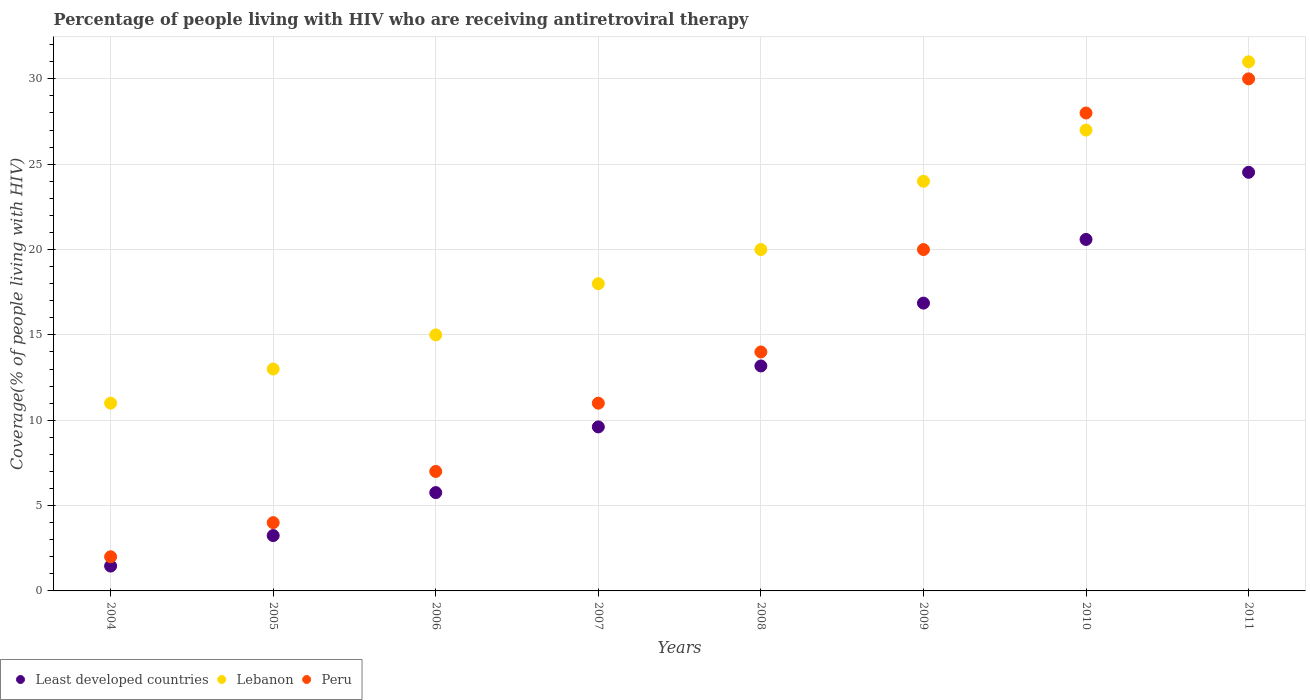What is the percentage of the HIV infected people who are receiving antiretroviral therapy in Least developed countries in 2009?
Your answer should be compact. 16.86. Across all years, what is the maximum percentage of the HIV infected people who are receiving antiretroviral therapy in Lebanon?
Provide a succinct answer. 31. Across all years, what is the minimum percentage of the HIV infected people who are receiving antiretroviral therapy in Peru?
Offer a very short reply. 2. What is the total percentage of the HIV infected people who are receiving antiretroviral therapy in Least developed countries in the graph?
Offer a terse response. 95.23. What is the difference between the percentage of the HIV infected people who are receiving antiretroviral therapy in Lebanon in 2007 and that in 2010?
Ensure brevity in your answer.  -9. What is the difference between the percentage of the HIV infected people who are receiving antiretroviral therapy in Peru in 2006 and the percentage of the HIV infected people who are receiving antiretroviral therapy in Least developed countries in 2010?
Your response must be concise. -13.59. What is the average percentage of the HIV infected people who are receiving antiretroviral therapy in Least developed countries per year?
Give a very brief answer. 11.9. In the year 2005, what is the difference between the percentage of the HIV infected people who are receiving antiretroviral therapy in Least developed countries and percentage of the HIV infected people who are receiving antiretroviral therapy in Peru?
Provide a succinct answer. -0.76. In how many years, is the percentage of the HIV infected people who are receiving antiretroviral therapy in Peru greater than 8 %?
Your answer should be very brief. 5. What is the ratio of the percentage of the HIV infected people who are receiving antiretroviral therapy in Least developed countries in 2004 to that in 2008?
Your answer should be very brief. 0.11. Is the percentage of the HIV infected people who are receiving antiretroviral therapy in Lebanon in 2007 less than that in 2009?
Keep it short and to the point. Yes. Is the difference between the percentage of the HIV infected people who are receiving antiretroviral therapy in Least developed countries in 2004 and 2010 greater than the difference between the percentage of the HIV infected people who are receiving antiretroviral therapy in Peru in 2004 and 2010?
Your answer should be compact. Yes. What is the difference between the highest and the lowest percentage of the HIV infected people who are receiving antiretroviral therapy in Least developed countries?
Make the answer very short. 23.07. Is the sum of the percentage of the HIV infected people who are receiving antiretroviral therapy in Least developed countries in 2005 and 2007 greater than the maximum percentage of the HIV infected people who are receiving antiretroviral therapy in Lebanon across all years?
Provide a succinct answer. No. Is it the case that in every year, the sum of the percentage of the HIV infected people who are receiving antiretroviral therapy in Least developed countries and percentage of the HIV infected people who are receiving antiretroviral therapy in Peru  is greater than the percentage of the HIV infected people who are receiving antiretroviral therapy in Lebanon?
Offer a very short reply. No. Is the percentage of the HIV infected people who are receiving antiretroviral therapy in Peru strictly less than the percentage of the HIV infected people who are receiving antiretroviral therapy in Lebanon over the years?
Provide a succinct answer. No. How many years are there in the graph?
Your answer should be very brief. 8. What is the difference between two consecutive major ticks on the Y-axis?
Make the answer very short. 5. Does the graph contain grids?
Your response must be concise. Yes. Where does the legend appear in the graph?
Provide a succinct answer. Bottom left. How many legend labels are there?
Ensure brevity in your answer.  3. What is the title of the graph?
Provide a short and direct response. Percentage of people living with HIV who are receiving antiretroviral therapy. Does "Canada" appear as one of the legend labels in the graph?
Give a very brief answer. No. What is the label or title of the Y-axis?
Give a very brief answer. Coverage(% of people living with HIV). What is the Coverage(% of people living with HIV) in Least developed countries in 2004?
Provide a short and direct response. 1.46. What is the Coverage(% of people living with HIV) in Peru in 2004?
Offer a very short reply. 2. What is the Coverage(% of people living with HIV) of Least developed countries in 2005?
Provide a short and direct response. 3.24. What is the Coverage(% of people living with HIV) of Lebanon in 2005?
Make the answer very short. 13. What is the Coverage(% of people living with HIV) of Peru in 2005?
Your answer should be very brief. 4. What is the Coverage(% of people living with HIV) in Least developed countries in 2006?
Offer a very short reply. 5.76. What is the Coverage(% of people living with HIV) of Lebanon in 2006?
Offer a terse response. 15. What is the Coverage(% of people living with HIV) in Peru in 2006?
Your answer should be very brief. 7. What is the Coverage(% of people living with HIV) of Least developed countries in 2007?
Provide a short and direct response. 9.61. What is the Coverage(% of people living with HIV) of Least developed countries in 2008?
Your answer should be compact. 13.18. What is the Coverage(% of people living with HIV) of Lebanon in 2008?
Ensure brevity in your answer.  20. What is the Coverage(% of people living with HIV) in Least developed countries in 2009?
Provide a short and direct response. 16.86. What is the Coverage(% of people living with HIV) of Lebanon in 2009?
Your answer should be compact. 24. What is the Coverage(% of people living with HIV) in Peru in 2009?
Offer a terse response. 20. What is the Coverage(% of people living with HIV) in Least developed countries in 2010?
Your response must be concise. 20.59. What is the Coverage(% of people living with HIV) of Lebanon in 2010?
Offer a terse response. 27. What is the Coverage(% of people living with HIV) of Least developed countries in 2011?
Provide a succinct answer. 24.53. What is the Coverage(% of people living with HIV) in Peru in 2011?
Your answer should be compact. 30. Across all years, what is the maximum Coverage(% of people living with HIV) of Least developed countries?
Make the answer very short. 24.53. Across all years, what is the minimum Coverage(% of people living with HIV) in Least developed countries?
Provide a short and direct response. 1.46. Across all years, what is the minimum Coverage(% of people living with HIV) in Lebanon?
Keep it short and to the point. 11. What is the total Coverage(% of people living with HIV) of Least developed countries in the graph?
Keep it short and to the point. 95.23. What is the total Coverage(% of people living with HIV) of Lebanon in the graph?
Make the answer very short. 159. What is the total Coverage(% of people living with HIV) of Peru in the graph?
Your answer should be very brief. 116. What is the difference between the Coverage(% of people living with HIV) in Least developed countries in 2004 and that in 2005?
Make the answer very short. -1.79. What is the difference between the Coverage(% of people living with HIV) of Least developed countries in 2004 and that in 2006?
Your response must be concise. -4.3. What is the difference between the Coverage(% of people living with HIV) in Peru in 2004 and that in 2006?
Provide a succinct answer. -5. What is the difference between the Coverage(% of people living with HIV) of Least developed countries in 2004 and that in 2007?
Provide a short and direct response. -8.15. What is the difference between the Coverage(% of people living with HIV) in Lebanon in 2004 and that in 2007?
Provide a short and direct response. -7. What is the difference between the Coverage(% of people living with HIV) of Peru in 2004 and that in 2007?
Offer a terse response. -9. What is the difference between the Coverage(% of people living with HIV) in Least developed countries in 2004 and that in 2008?
Give a very brief answer. -11.72. What is the difference between the Coverage(% of people living with HIV) in Lebanon in 2004 and that in 2008?
Your answer should be compact. -9. What is the difference between the Coverage(% of people living with HIV) in Least developed countries in 2004 and that in 2009?
Your answer should be very brief. -15.41. What is the difference between the Coverage(% of people living with HIV) of Least developed countries in 2004 and that in 2010?
Make the answer very short. -19.14. What is the difference between the Coverage(% of people living with HIV) in Lebanon in 2004 and that in 2010?
Keep it short and to the point. -16. What is the difference between the Coverage(% of people living with HIV) of Least developed countries in 2004 and that in 2011?
Offer a very short reply. -23.07. What is the difference between the Coverage(% of people living with HIV) of Peru in 2004 and that in 2011?
Provide a short and direct response. -28. What is the difference between the Coverage(% of people living with HIV) in Least developed countries in 2005 and that in 2006?
Offer a very short reply. -2.52. What is the difference between the Coverage(% of people living with HIV) of Lebanon in 2005 and that in 2006?
Ensure brevity in your answer.  -2. What is the difference between the Coverage(% of people living with HIV) in Peru in 2005 and that in 2006?
Ensure brevity in your answer.  -3. What is the difference between the Coverage(% of people living with HIV) in Least developed countries in 2005 and that in 2007?
Offer a very short reply. -6.37. What is the difference between the Coverage(% of people living with HIV) of Lebanon in 2005 and that in 2007?
Your answer should be compact. -5. What is the difference between the Coverage(% of people living with HIV) in Least developed countries in 2005 and that in 2008?
Your answer should be compact. -9.94. What is the difference between the Coverage(% of people living with HIV) of Peru in 2005 and that in 2008?
Your answer should be very brief. -10. What is the difference between the Coverage(% of people living with HIV) of Least developed countries in 2005 and that in 2009?
Give a very brief answer. -13.62. What is the difference between the Coverage(% of people living with HIV) of Lebanon in 2005 and that in 2009?
Offer a very short reply. -11. What is the difference between the Coverage(% of people living with HIV) of Least developed countries in 2005 and that in 2010?
Your response must be concise. -17.35. What is the difference between the Coverage(% of people living with HIV) of Lebanon in 2005 and that in 2010?
Offer a very short reply. -14. What is the difference between the Coverage(% of people living with HIV) in Peru in 2005 and that in 2010?
Keep it short and to the point. -24. What is the difference between the Coverage(% of people living with HIV) of Least developed countries in 2005 and that in 2011?
Give a very brief answer. -21.28. What is the difference between the Coverage(% of people living with HIV) of Lebanon in 2005 and that in 2011?
Give a very brief answer. -18. What is the difference between the Coverage(% of people living with HIV) of Least developed countries in 2006 and that in 2007?
Keep it short and to the point. -3.85. What is the difference between the Coverage(% of people living with HIV) in Peru in 2006 and that in 2007?
Your answer should be compact. -4. What is the difference between the Coverage(% of people living with HIV) of Least developed countries in 2006 and that in 2008?
Give a very brief answer. -7.42. What is the difference between the Coverage(% of people living with HIV) of Lebanon in 2006 and that in 2008?
Keep it short and to the point. -5. What is the difference between the Coverage(% of people living with HIV) in Peru in 2006 and that in 2008?
Keep it short and to the point. -7. What is the difference between the Coverage(% of people living with HIV) of Least developed countries in 2006 and that in 2009?
Your answer should be compact. -11.1. What is the difference between the Coverage(% of people living with HIV) of Lebanon in 2006 and that in 2009?
Your response must be concise. -9. What is the difference between the Coverage(% of people living with HIV) in Peru in 2006 and that in 2009?
Provide a short and direct response. -13. What is the difference between the Coverage(% of people living with HIV) of Least developed countries in 2006 and that in 2010?
Your answer should be very brief. -14.83. What is the difference between the Coverage(% of people living with HIV) in Peru in 2006 and that in 2010?
Your answer should be very brief. -21. What is the difference between the Coverage(% of people living with HIV) in Least developed countries in 2006 and that in 2011?
Keep it short and to the point. -18.76. What is the difference between the Coverage(% of people living with HIV) of Peru in 2006 and that in 2011?
Offer a terse response. -23. What is the difference between the Coverage(% of people living with HIV) in Least developed countries in 2007 and that in 2008?
Your response must be concise. -3.57. What is the difference between the Coverage(% of people living with HIV) in Lebanon in 2007 and that in 2008?
Keep it short and to the point. -2. What is the difference between the Coverage(% of people living with HIV) of Least developed countries in 2007 and that in 2009?
Ensure brevity in your answer.  -7.25. What is the difference between the Coverage(% of people living with HIV) of Lebanon in 2007 and that in 2009?
Keep it short and to the point. -6. What is the difference between the Coverage(% of people living with HIV) in Least developed countries in 2007 and that in 2010?
Keep it short and to the point. -10.98. What is the difference between the Coverage(% of people living with HIV) of Lebanon in 2007 and that in 2010?
Your answer should be very brief. -9. What is the difference between the Coverage(% of people living with HIV) in Least developed countries in 2007 and that in 2011?
Offer a very short reply. -14.92. What is the difference between the Coverage(% of people living with HIV) in Peru in 2007 and that in 2011?
Give a very brief answer. -19. What is the difference between the Coverage(% of people living with HIV) of Least developed countries in 2008 and that in 2009?
Give a very brief answer. -3.68. What is the difference between the Coverage(% of people living with HIV) in Peru in 2008 and that in 2009?
Give a very brief answer. -6. What is the difference between the Coverage(% of people living with HIV) of Least developed countries in 2008 and that in 2010?
Your answer should be compact. -7.41. What is the difference between the Coverage(% of people living with HIV) in Peru in 2008 and that in 2010?
Provide a short and direct response. -14. What is the difference between the Coverage(% of people living with HIV) of Least developed countries in 2008 and that in 2011?
Your answer should be very brief. -11.35. What is the difference between the Coverage(% of people living with HIV) in Lebanon in 2008 and that in 2011?
Give a very brief answer. -11. What is the difference between the Coverage(% of people living with HIV) in Least developed countries in 2009 and that in 2010?
Provide a short and direct response. -3.73. What is the difference between the Coverage(% of people living with HIV) in Lebanon in 2009 and that in 2010?
Make the answer very short. -3. What is the difference between the Coverage(% of people living with HIV) in Peru in 2009 and that in 2010?
Offer a very short reply. -8. What is the difference between the Coverage(% of people living with HIV) in Least developed countries in 2009 and that in 2011?
Provide a succinct answer. -7.66. What is the difference between the Coverage(% of people living with HIV) of Least developed countries in 2010 and that in 2011?
Give a very brief answer. -3.93. What is the difference between the Coverage(% of people living with HIV) of Lebanon in 2010 and that in 2011?
Make the answer very short. -4. What is the difference between the Coverage(% of people living with HIV) in Least developed countries in 2004 and the Coverage(% of people living with HIV) in Lebanon in 2005?
Your answer should be compact. -11.54. What is the difference between the Coverage(% of people living with HIV) in Least developed countries in 2004 and the Coverage(% of people living with HIV) in Peru in 2005?
Offer a terse response. -2.54. What is the difference between the Coverage(% of people living with HIV) of Least developed countries in 2004 and the Coverage(% of people living with HIV) of Lebanon in 2006?
Offer a terse response. -13.54. What is the difference between the Coverage(% of people living with HIV) of Least developed countries in 2004 and the Coverage(% of people living with HIV) of Peru in 2006?
Your answer should be very brief. -5.54. What is the difference between the Coverage(% of people living with HIV) of Lebanon in 2004 and the Coverage(% of people living with HIV) of Peru in 2006?
Offer a very short reply. 4. What is the difference between the Coverage(% of people living with HIV) of Least developed countries in 2004 and the Coverage(% of people living with HIV) of Lebanon in 2007?
Your answer should be very brief. -16.54. What is the difference between the Coverage(% of people living with HIV) of Least developed countries in 2004 and the Coverage(% of people living with HIV) of Peru in 2007?
Offer a terse response. -9.54. What is the difference between the Coverage(% of people living with HIV) of Lebanon in 2004 and the Coverage(% of people living with HIV) of Peru in 2007?
Your answer should be very brief. 0. What is the difference between the Coverage(% of people living with HIV) in Least developed countries in 2004 and the Coverage(% of people living with HIV) in Lebanon in 2008?
Make the answer very short. -18.54. What is the difference between the Coverage(% of people living with HIV) in Least developed countries in 2004 and the Coverage(% of people living with HIV) in Peru in 2008?
Your answer should be compact. -12.54. What is the difference between the Coverage(% of people living with HIV) of Least developed countries in 2004 and the Coverage(% of people living with HIV) of Lebanon in 2009?
Keep it short and to the point. -22.54. What is the difference between the Coverage(% of people living with HIV) of Least developed countries in 2004 and the Coverage(% of people living with HIV) of Peru in 2009?
Offer a terse response. -18.54. What is the difference between the Coverage(% of people living with HIV) in Least developed countries in 2004 and the Coverage(% of people living with HIV) in Lebanon in 2010?
Ensure brevity in your answer.  -25.54. What is the difference between the Coverage(% of people living with HIV) in Least developed countries in 2004 and the Coverage(% of people living with HIV) in Peru in 2010?
Ensure brevity in your answer.  -26.54. What is the difference between the Coverage(% of people living with HIV) of Least developed countries in 2004 and the Coverage(% of people living with HIV) of Lebanon in 2011?
Provide a succinct answer. -29.54. What is the difference between the Coverage(% of people living with HIV) of Least developed countries in 2004 and the Coverage(% of people living with HIV) of Peru in 2011?
Your answer should be compact. -28.54. What is the difference between the Coverage(% of people living with HIV) in Lebanon in 2004 and the Coverage(% of people living with HIV) in Peru in 2011?
Give a very brief answer. -19. What is the difference between the Coverage(% of people living with HIV) of Least developed countries in 2005 and the Coverage(% of people living with HIV) of Lebanon in 2006?
Keep it short and to the point. -11.76. What is the difference between the Coverage(% of people living with HIV) in Least developed countries in 2005 and the Coverage(% of people living with HIV) in Peru in 2006?
Give a very brief answer. -3.76. What is the difference between the Coverage(% of people living with HIV) in Least developed countries in 2005 and the Coverage(% of people living with HIV) in Lebanon in 2007?
Offer a terse response. -14.76. What is the difference between the Coverage(% of people living with HIV) of Least developed countries in 2005 and the Coverage(% of people living with HIV) of Peru in 2007?
Offer a terse response. -7.76. What is the difference between the Coverage(% of people living with HIV) of Least developed countries in 2005 and the Coverage(% of people living with HIV) of Lebanon in 2008?
Ensure brevity in your answer.  -16.76. What is the difference between the Coverage(% of people living with HIV) of Least developed countries in 2005 and the Coverage(% of people living with HIV) of Peru in 2008?
Your answer should be very brief. -10.76. What is the difference between the Coverage(% of people living with HIV) in Lebanon in 2005 and the Coverage(% of people living with HIV) in Peru in 2008?
Keep it short and to the point. -1. What is the difference between the Coverage(% of people living with HIV) in Least developed countries in 2005 and the Coverage(% of people living with HIV) in Lebanon in 2009?
Offer a very short reply. -20.76. What is the difference between the Coverage(% of people living with HIV) of Least developed countries in 2005 and the Coverage(% of people living with HIV) of Peru in 2009?
Give a very brief answer. -16.76. What is the difference between the Coverage(% of people living with HIV) of Least developed countries in 2005 and the Coverage(% of people living with HIV) of Lebanon in 2010?
Your response must be concise. -23.76. What is the difference between the Coverage(% of people living with HIV) of Least developed countries in 2005 and the Coverage(% of people living with HIV) of Peru in 2010?
Give a very brief answer. -24.76. What is the difference between the Coverage(% of people living with HIV) of Lebanon in 2005 and the Coverage(% of people living with HIV) of Peru in 2010?
Provide a succinct answer. -15. What is the difference between the Coverage(% of people living with HIV) of Least developed countries in 2005 and the Coverage(% of people living with HIV) of Lebanon in 2011?
Offer a very short reply. -27.76. What is the difference between the Coverage(% of people living with HIV) of Least developed countries in 2005 and the Coverage(% of people living with HIV) of Peru in 2011?
Your answer should be compact. -26.76. What is the difference between the Coverage(% of people living with HIV) in Lebanon in 2005 and the Coverage(% of people living with HIV) in Peru in 2011?
Offer a terse response. -17. What is the difference between the Coverage(% of people living with HIV) in Least developed countries in 2006 and the Coverage(% of people living with HIV) in Lebanon in 2007?
Give a very brief answer. -12.24. What is the difference between the Coverage(% of people living with HIV) in Least developed countries in 2006 and the Coverage(% of people living with HIV) in Peru in 2007?
Give a very brief answer. -5.24. What is the difference between the Coverage(% of people living with HIV) of Least developed countries in 2006 and the Coverage(% of people living with HIV) of Lebanon in 2008?
Your answer should be compact. -14.24. What is the difference between the Coverage(% of people living with HIV) in Least developed countries in 2006 and the Coverage(% of people living with HIV) in Peru in 2008?
Make the answer very short. -8.24. What is the difference between the Coverage(% of people living with HIV) in Least developed countries in 2006 and the Coverage(% of people living with HIV) in Lebanon in 2009?
Provide a short and direct response. -18.24. What is the difference between the Coverage(% of people living with HIV) of Least developed countries in 2006 and the Coverage(% of people living with HIV) of Peru in 2009?
Provide a succinct answer. -14.24. What is the difference between the Coverage(% of people living with HIV) of Least developed countries in 2006 and the Coverage(% of people living with HIV) of Lebanon in 2010?
Your answer should be compact. -21.24. What is the difference between the Coverage(% of people living with HIV) in Least developed countries in 2006 and the Coverage(% of people living with HIV) in Peru in 2010?
Keep it short and to the point. -22.24. What is the difference between the Coverage(% of people living with HIV) of Lebanon in 2006 and the Coverage(% of people living with HIV) of Peru in 2010?
Make the answer very short. -13. What is the difference between the Coverage(% of people living with HIV) of Least developed countries in 2006 and the Coverage(% of people living with HIV) of Lebanon in 2011?
Make the answer very short. -25.24. What is the difference between the Coverage(% of people living with HIV) in Least developed countries in 2006 and the Coverage(% of people living with HIV) in Peru in 2011?
Make the answer very short. -24.24. What is the difference between the Coverage(% of people living with HIV) in Least developed countries in 2007 and the Coverage(% of people living with HIV) in Lebanon in 2008?
Provide a succinct answer. -10.39. What is the difference between the Coverage(% of people living with HIV) of Least developed countries in 2007 and the Coverage(% of people living with HIV) of Peru in 2008?
Keep it short and to the point. -4.39. What is the difference between the Coverage(% of people living with HIV) of Least developed countries in 2007 and the Coverage(% of people living with HIV) of Lebanon in 2009?
Offer a terse response. -14.39. What is the difference between the Coverage(% of people living with HIV) of Least developed countries in 2007 and the Coverage(% of people living with HIV) of Peru in 2009?
Your answer should be very brief. -10.39. What is the difference between the Coverage(% of people living with HIV) in Least developed countries in 2007 and the Coverage(% of people living with HIV) in Lebanon in 2010?
Give a very brief answer. -17.39. What is the difference between the Coverage(% of people living with HIV) in Least developed countries in 2007 and the Coverage(% of people living with HIV) in Peru in 2010?
Offer a very short reply. -18.39. What is the difference between the Coverage(% of people living with HIV) of Lebanon in 2007 and the Coverage(% of people living with HIV) of Peru in 2010?
Keep it short and to the point. -10. What is the difference between the Coverage(% of people living with HIV) in Least developed countries in 2007 and the Coverage(% of people living with HIV) in Lebanon in 2011?
Provide a short and direct response. -21.39. What is the difference between the Coverage(% of people living with HIV) of Least developed countries in 2007 and the Coverage(% of people living with HIV) of Peru in 2011?
Offer a very short reply. -20.39. What is the difference between the Coverage(% of people living with HIV) of Least developed countries in 2008 and the Coverage(% of people living with HIV) of Lebanon in 2009?
Make the answer very short. -10.82. What is the difference between the Coverage(% of people living with HIV) of Least developed countries in 2008 and the Coverage(% of people living with HIV) of Peru in 2009?
Give a very brief answer. -6.82. What is the difference between the Coverage(% of people living with HIV) in Least developed countries in 2008 and the Coverage(% of people living with HIV) in Lebanon in 2010?
Provide a succinct answer. -13.82. What is the difference between the Coverage(% of people living with HIV) of Least developed countries in 2008 and the Coverage(% of people living with HIV) of Peru in 2010?
Make the answer very short. -14.82. What is the difference between the Coverage(% of people living with HIV) of Least developed countries in 2008 and the Coverage(% of people living with HIV) of Lebanon in 2011?
Offer a very short reply. -17.82. What is the difference between the Coverage(% of people living with HIV) in Least developed countries in 2008 and the Coverage(% of people living with HIV) in Peru in 2011?
Provide a succinct answer. -16.82. What is the difference between the Coverage(% of people living with HIV) in Least developed countries in 2009 and the Coverage(% of people living with HIV) in Lebanon in 2010?
Your answer should be very brief. -10.14. What is the difference between the Coverage(% of people living with HIV) of Least developed countries in 2009 and the Coverage(% of people living with HIV) of Peru in 2010?
Ensure brevity in your answer.  -11.14. What is the difference between the Coverage(% of people living with HIV) of Least developed countries in 2009 and the Coverage(% of people living with HIV) of Lebanon in 2011?
Provide a succinct answer. -14.14. What is the difference between the Coverage(% of people living with HIV) in Least developed countries in 2009 and the Coverage(% of people living with HIV) in Peru in 2011?
Your answer should be very brief. -13.14. What is the difference between the Coverage(% of people living with HIV) of Lebanon in 2009 and the Coverage(% of people living with HIV) of Peru in 2011?
Your answer should be very brief. -6. What is the difference between the Coverage(% of people living with HIV) in Least developed countries in 2010 and the Coverage(% of people living with HIV) in Lebanon in 2011?
Ensure brevity in your answer.  -10.41. What is the difference between the Coverage(% of people living with HIV) of Least developed countries in 2010 and the Coverage(% of people living with HIV) of Peru in 2011?
Your response must be concise. -9.41. What is the difference between the Coverage(% of people living with HIV) of Lebanon in 2010 and the Coverage(% of people living with HIV) of Peru in 2011?
Provide a short and direct response. -3. What is the average Coverage(% of people living with HIV) of Least developed countries per year?
Give a very brief answer. 11.9. What is the average Coverage(% of people living with HIV) of Lebanon per year?
Provide a short and direct response. 19.88. In the year 2004, what is the difference between the Coverage(% of people living with HIV) in Least developed countries and Coverage(% of people living with HIV) in Lebanon?
Provide a short and direct response. -9.54. In the year 2004, what is the difference between the Coverage(% of people living with HIV) in Least developed countries and Coverage(% of people living with HIV) in Peru?
Make the answer very short. -0.54. In the year 2004, what is the difference between the Coverage(% of people living with HIV) of Lebanon and Coverage(% of people living with HIV) of Peru?
Your answer should be compact. 9. In the year 2005, what is the difference between the Coverage(% of people living with HIV) in Least developed countries and Coverage(% of people living with HIV) in Lebanon?
Make the answer very short. -9.76. In the year 2005, what is the difference between the Coverage(% of people living with HIV) of Least developed countries and Coverage(% of people living with HIV) of Peru?
Make the answer very short. -0.76. In the year 2006, what is the difference between the Coverage(% of people living with HIV) of Least developed countries and Coverage(% of people living with HIV) of Lebanon?
Provide a short and direct response. -9.24. In the year 2006, what is the difference between the Coverage(% of people living with HIV) of Least developed countries and Coverage(% of people living with HIV) of Peru?
Keep it short and to the point. -1.24. In the year 2006, what is the difference between the Coverage(% of people living with HIV) of Lebanon and Coverage(% of people living with HIV) of Peru?
Provide a short and direct response. 8. In the year 2007, what is the difference between the Coverage(% of people living with HIV) of Least developed countries and Coverage(% of people living with HIV) of Lebanon?
Provide a short and direct response. -8.39. In the year 2007, what is the difference between the Coverage(% of people living with HIV) in Least developed countries and Coverage(% of people living with HIV) in Peru?
Your response must be concise. -1.39. In the year 2007, what is the difference between the Coverage(% of people living with HIV) of Lebanon and Coverage(% of people living with HIV) of Peru?
Offer a very short reply. 7. In the year 2008, what is the difference between the Coverage(% of people living with HIV) in Least developed countries and Coverage(% of people living with HIV) in Lebanon?
Offer a terse response. -6.82. In the year 2008, what is the difference between the Coverage(% of people living with HIV) of Least developed countries and Coverage(% of people living with HIV) of Peru?
Ensure brevity in your answer.  -0.82. In the year 2008, what is the difference between the Coverage(% of people living with HIV) in Lebanon and Coverage(% of people living with HIV) in Peru?
Keep it short and to the point. 6. In the year 2009, what is the difference between the Coverage(% of people living with HIV) of Least developed countries and Coverage(% of people living with HIV) of Lebanon?
Provide a short and direct response. -7.14. In the year 2009, what is the difference between the Coverage(% of people living with HIV) in Least developed countries and Coverage(% of people living with HIV) in Peru?
Your answer should be compact. -3.14. In the year 2010, what is the difference between the Coverage(% of people living with HIV) in Least developed countries and Coverage(% of people living with HIV) in Lebanon?
Keep it short and to the point. -6.41. In the year 2010, what is the difference between the Coverage(% of people living with HIV) in Least developed countries and Coverage(% of people living with HIV) in Peru?
Provide a short and direct response. -7.41. In the year 2010, what is the difference between the Coverage(% of people living with HIV) in Lebanon and Coverage(% of people living with HIV) in Peru?
Keep it short and to the point. -1. In the year 2011, what is the difference between the Coverage(% of people living with HIV) of Least developed countries and Coverage(% of people living with HIV) of Lebanon?
Keep it short and to the point. -6.47. In the year 2011, what is the difference between the Coverage(% of people living with HIV) in Least developed countries and Coverage(% of people living with HIV) in Peru?
Offer a terse response. -5.47. In the year 2011, what is the difference between the Coverage(% of people living with HIV) of Lebanon and Coverage(% of people living with HIV) of Peru?
Provide a short and direct response. 1. What is the ratio of the Coverage(% of people living with HIV) in Least developed countries in 2004 to that in 2005?
Ensure brevity in your answer.  0.45. What is the ratio of the Coverage(% of people living with HIV) of Lebanon in 2004 to that in 2005?
Your response must be concise. 0.85. What is the ratio of the Coverage(% of people living with HIV) in Least developed countries in 2004 to that in 2006?
Offer a very short reply. 0.25. What is the ratio of the Coverage(% of people living with HIV) of Lebanon in 2004 to that in 2006?
Your response must be concise. 0.73. What is the ratio of the Coverage(% of people living with HIV) in Peru in 2004 to that in 2006?
Provide a succinct answer. 0.29. What is the ratio of the Coverage(% of people living with HIV) in Least developed countries in 2004 to that in 2007?
Provide a succinct answer. 0.15. What is the ratio of the Coverage(% of people living with HIV) in Lebanon in 2004 to that in 2007?
Keep it short and to the point. 0.61. What is the ratio of the Coverage(% of people living with HIV) of Peru in 2004 to that in 2007?
Give a very brief answer. 0.18. What is the ratio of the Coverage(% of people living with HIV) in Least developed countries in 2004 to that in 2008?
Offer a very short reply. 0.11. What is the ratio of the Coverage(% of people living with HIV) in Lebanon in 2004 to that in 2008?
Offer a terse response. 0.55. What is the ratio of the Coverage(% of people living with HIV) of Peru in 2004 to that in 2008?
Give a very brief answer. 0.14. What is the ratio of the Coverage(% of people living with HIV) in Least developed countries in 2004 to that in 2009?
Ensure brevity in your answer.  0.09. What is the ratio of the Coverage(% of people living with HIV) in Lebanon in 2004 to that in 2009?
Offer a terse response. 0.46. What is the ratio of the Coverage(% of people living with HIV) in Least developed countries in 2004 to that in 2010?
Ensure brevity in your answer.  0.07. What is the ratio of the Coverage(% of people living with HIV) of Lebanon in 2004 to that in 2010?
Keep it short and to the point. 0.41. What is the ratio of the Coverage(% of people living with HIV) of Peru in 2004 to that in 2010?
Provide a succinct answer. 0.07. What is the ratio of the Coverage(% of people living with HIV) in Least developed countries in 2004 to that in 2011?
Offer a very short reply. 0.06. What is the ratio of the Coverage(% of people living with HIV) in Lebanon in 2004 to that in 2011?
Your response must be concise. 0.35. What is the ratio of the Coverage(% of people living with HIV) in Peru in 2004 to that in 2011?
Offer a very short reply. 0.07. What is the ratio of the Coverage(% of people living with HIV) in Least developed countries in 2005 to that in 2006?
Keep it short and to the point. 0.56. What is the ratio of the Coverage(% of people living with HIV) of Lebanon in 2005 to that in 2006?
Offer a very short reply. 0.87. What is the ratio of the Coverage(% of people living with HIV) in Least developed countries in 2005 to that in 2007?
Your answer should be compact. 0.34. What is the ratio of the Coverage(% of people living with HIV) in Lebanon in 2005 to that in 2007?
Ensure brevity in your answer.  0.72. What is the ratio of the Coverage(% of people living with HIV) in Peru in 2005 to that in 2007?
Provide a short and direct response. 0.36. What is the ratio of the Coverage(% of people living with HIV) of Least developed countries in 2005 to that in 2008?
Offer a very short reply. 0.25. What is the ratio of the Coverage(% of people living with HIV) in Lebanon in 2005 to that in 2008?
Your response must be concise. 0.65. What is the ratio of the Coverage(% of people living with HIV) in Peru in 2005 to that in 2008?
Ensure brevity in your answer.  0.29. What is the ratio of the Coverage(% of people living with HIV) of Least developed countries in 2005 to that in 2009?
Provide a succinct answer. 0.19. What is the ratio of the Coverage(% of people living with HIV) of Lebanon in 2005 to that in 2009?
Make the answer very short. 0.54. What is the ratio of the Coverage(% of people living with HIV) in Peru in 2005 to that in 2009?
Provide a short and direct response. 0.2. What is the ratio of the Coverage(% of people living with HIV) in Least developed countries in 2005 to that in 2010?
Your answer should be compact. 0.16. What is the ratio of the Coverage(% of people living with HIV) in Lebanon in 2005 to that in 2010?
Give a very brief answer. 0.48. What is the ratio of the Coverage(% of people living with HIV) of Peru in 2005 to that in 2010?
Give a very brief answer. 0.14. What is the ratio of the Coverage(% of people living with HIV) in Least developed countries in 2005 to that in 2011?
Ensure brevity in your answer.  0.13. What is the ratio of the Coverage(% of people living with HIV) of Lebanon in 2005 to that in 2011?
Provide a succinct answer. 0.42. What is the ratio of the Coverage(% of people living with HIV) of Peru in 2005 to that in 2011?
Your answer should be very brief. 0.13. What is the ratio of the Coverage(% of people living with HIV) of Least developed countries in 2006 to that in 2007?
Provide a short and direct response. 0.6. What is the ratio of the Coverage(% of people living with HIV) in Peru in 2006 to that in 2007?
Provide a succinct answer. 0.64. What is the ratio of the Coverage(% of people living with HIV) of Least developed countries in 2006 to that in 2008?
Provide a short and direct response. 0.44. What is the ratio of the Coverage(% of people living with HIV) of Lebanon in 2006 to that in 2008?
Offer a terse response. 0.75. What is the ratio of the Coverage(% of people living with HIV) of Peru in 2006 to that in 2008?
Offer a very short reply. 0.5. What is the ratio of the Coverage(% of people living with HIV) in Least developed countries in 2006 to that in 2009?
Your response must be concise. 0.34. What is the ratio of the Coverage(% of people living with HIV) of Lebanon in 2006 to that in 2009?
Your answer should be very brief. 0.62. What is the ratio of the Coverage(% of people living with HIV) of Peru in 2006 to that in 2009?
Your response must be concise. 0.35. What is the ratio of the Coverage(% of people living with HIV) in Least developed countries in 2006 to that in 2010?
Make the answer very short. 0.28. What is the ratio of the Coverage(% of people living with HIV) of Lebanon in 2006 to that in 2010?
Provide a succinct answer. 0.56. What is the ratio of the Coverage(% of people living with HIV) of Peru in 2006 to that in 2010?
Make the answer very short. 0.25. What is the ratio of the Coverage(% of people living with HIV) of Least developed countries in 2006 to that in 2011?
Your response must be concise. 0.23. What is the ratio of the Coverage(% of people living with HIV) in Lebanon in 2006 to that in 2011?
Ensure brevity in your answer.  0.48. What is the ratio of the Coverage(% of people living with HIV) in Peru in 2006 to that in 2011?
Ensure brevity in your answer.  0.23. What is the ratio of the Coverage(% of people living with HIV) in Least developed countries in 2007 to that in 2008?
Keep it short and to the point. 0.73. What is the ratio of the Coverage(% of people living with HIV) in Lebanon in 2007 to that in 2008?
Ensure brevity in your answer.  0.9. What is the ratio of the Coverage(% of people living with HIV) of Peru in 2007 to that in 2008?
Your answer should be very brief. 0.79. What is the ratio of the Coverage(% of people living with HIV) in Least developed countries in 2007 to that in 2009?
Keep it short and to the point. 0.57. What is the ratio of the Coverage(% of people living with HIV) in Peru in 2007 to that in 2009?
Give a very brief answer. 0.55. What is the ratio of the Coverage(% of people living with HIV) in Least developed countries in 2007 to that in 2010?
Your answer should be compact. 0.47. What is the ratio of the Coverage(% of people living with HIV) of Peru in 2007 to that in 2010?
Ensure brevity in your answer.  0.39. What is the ratio of the Coverage(% of people living with HIV) in Least developed countries in 2007 to that in 2011?
Offer a terse response. 0.39. What is the ratio of the Coverage(% of people living with HIV) of Lebanon in 2007 to that in 2011?
Your response must be concise. 0.58. What is the ratio of the Coverage(% of people living with HIV) of Peru in 2007 to that in 2011?
Offer a very short reply. 0.37. What is the ratio of the Coverage(% of people living with HIV) in Least developed countries in 2008 to that in 2009?
Offer a terse response. 0.78. What is the ratio of the Coverage(% of people living with HIV) of Least developed countries in 2008 to that in 2010?
Your answer should be compact. 0.64. What is the ratio of the Coverage(% of people living with HIV) in Lebanon in 2008 to that in 2010?
Offer a very short reply. 0.74. What is the ratio of the Coverage(% of people living with HIV) in Least developed countries in 2008 to that in 2011?
Your answer should be compact. 0.54. What is the ratio of the Coverage(% of people living with HIV) in Lebanon in 2008 to that in 2011?
Give a very brief answer. 0.65. What is the ratio of the Coverage(% of people living with HIV) of Peru in 2008 to that in 2011?
Your answer should be very brief. 0.47. What is the ratio of the Coverage(% of people living with HIV) in Least developed countries in 2009 to that in 2010?
Provide a short and direct response. 0.82. What is the ratio of the Coverage(% of people living with HIV) of Lebanon in 2009 to that in 2010?
Your answer should be compact. 0.89. What is the ratio of the Coverage(% of people living with HIV) in Least developed countries in 2009 to that in 2011?
Your answer should be compact. 0.69. What is the ratio of the Coverage(% of people living with HIV) of Lebanon in 2009 to that in 2011?
Your answer should be very brief. 0.77. What is the ratio of the Coverage(% of people living with HIV) of Least developed countries in 2010 to that in 2011?
Your answer should be compact. 0.84. What is the ratio of the Coverage(% of people living with HIV) in Lebanon in 2010 to that in 2011?
Give a very brief answer. 0.87. What is the ratio of the Coverage(% of people living with HIV) of Peru in 2010 to that in 2011?
Make the answer very short. 0.93. What is the difference between the highest and the second highest Coverage(% of people living with HIV) of Least developed countries?
Give a very brief answer. 3.93. What is the difference between the highest and the second highest Coverage(% of people living with HIV) of Lebanon?
Ensure brevity in your answer.  4. What is the difference between the highest and the second highest Coverage(% of people living with HIV) of Peru?
Your response must be concise. 2. What is the difference between the highest and the lowest Coverage(% of people living with HIV) of Least developed countries?
Keep it short and to the point. 23.07. What is the difference between the highest and the lowest Coverage(% of people living with HIV) in Peru?
Your answer should be compact. 28. 